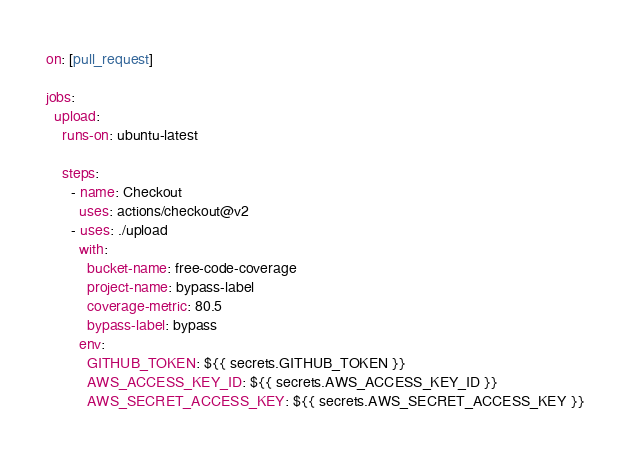Convert code to text. <code><loc_0><loc_0><loc_500><loc_500><_YAML_>on: [pull_request]

jobs:
  upload:
    runs-on: ubuntu-latest

    steps:
      - name: Checkout
        uses: actions/checkout@v2
      - uses: ./upload
        with:
          bucket-name: free-code-coverage
          project-name: bypass-label
          coverage-metric: 80.5
          bypass-label: bypass
        env:
          GITHUB_TOKEN: ${{ secrets.GITHUB_TOKEN }}
          AWS_ACCESS_KEY_ID: ${{ secrets.AWS_ACCESS_KEY_ID }}
          AWS_SECRET_ACCESS_KEY: ${{ secrets.AWS_SECRET_ACCESS_KEY }}
</code> 